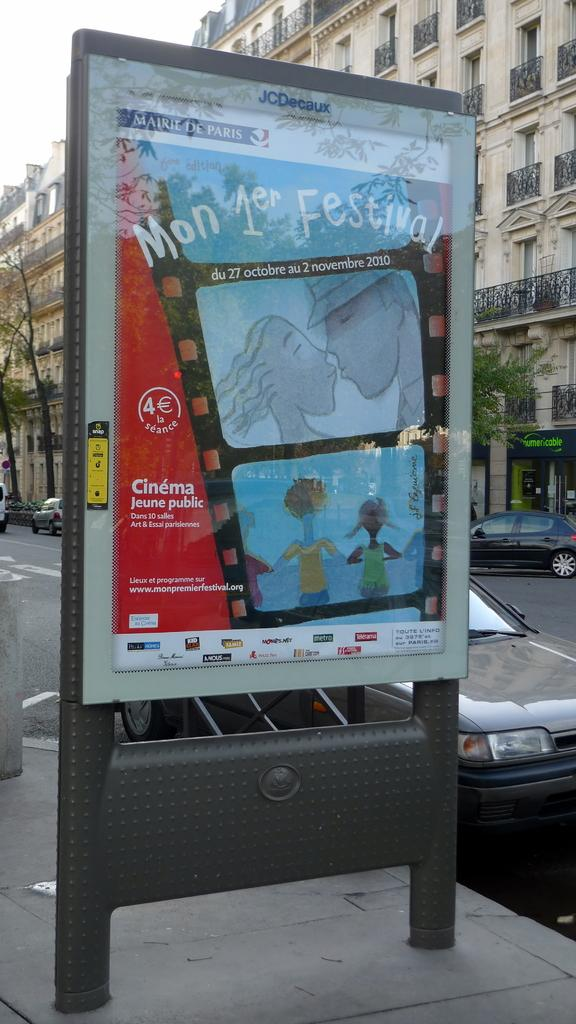<image>
Render a clear and concise summary of the photo. An outdoor street sign with a poster from Cinema Jeune public with an animated film role featuring a couple kissing. 